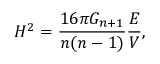<formula> <loc_0><loc_0><loc_500><loc_500>H ^ { 2 } = \frac { 1 6 \pi G _ { n + 1 } } { n ( n - 1 ) } \frac { E } { V } ,</formula> 